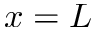Convert formula to latex. <formula><loc_0><loc_0><loc_500><loc_500>x = L</formula> 